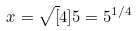<formula> <loc_0><loc_0><loc_500><loc_500>x = \sqrt { [ } 4 ] { 5 } = 5 ^ { 1 / 4 }</formula> 